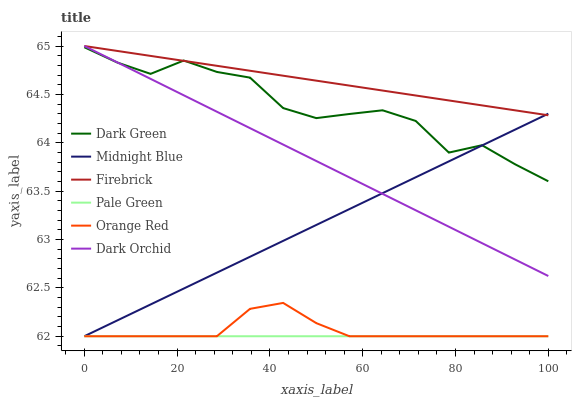Does Pale Green have the minimum area under the curve?
Answer yes or no. Yes. Does Firebrick have the maximum area under the curve?
Answer yes or no. Yes. Does Dark Orchid have the minimum area under the curve?
Answer yes or no. No. Does Dark Orchid have the maximum area under the curve?
Answer yes or no. No. Is Pale Green the smoothest?
Answer yes or no. Yes. Is Dark Green the roughest?
Answer yes or no. Yes. Is Firebrick the smoothest?
Answer yes or no. No. Is Firebrick the roughest?
Answer yes or no. No. Does Midnight Blue have the lowest value?
Answer yes or no. Yes. Does Dark Orchid have the lowest value?
Answer yes or no. No. Does Dark Orchid have the highest value?
Answer yes or no. Yes. Does Pale Green have the highest value?
Answer yes or no. No. Is Orange Red less than Dark Green?
Answer yes or no. Yes. Is Dark Green greater than Orange Red?
Answer yes or no. Yes. Does Midnight Blue intersect Firebrick?
Answer yes or no. Yes. Is Midnight Blue less than Firebrick?
Answer yes or no. No. Is Midnight Blue greater than Firebrick?
Answer yes or no. No. Does Orange Red intersect Dark Green?
Answer yes or no. No. 